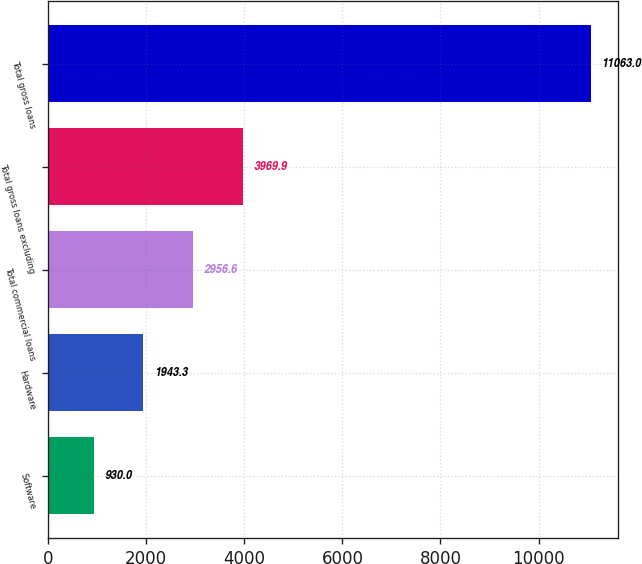Convert chart. <chart><loc_0><loc_0><loc_500><loc_500><bar_chart><fcel>Software<fcel>Hardware<fcel>Total commercial loans<fcel>Total gross loans excluding<fcel>Total gross loans<nl><fcel>930<fcel>1943.3<fcel>2956.6<fcel>3969.9<fcel>11063<nl></chart> 